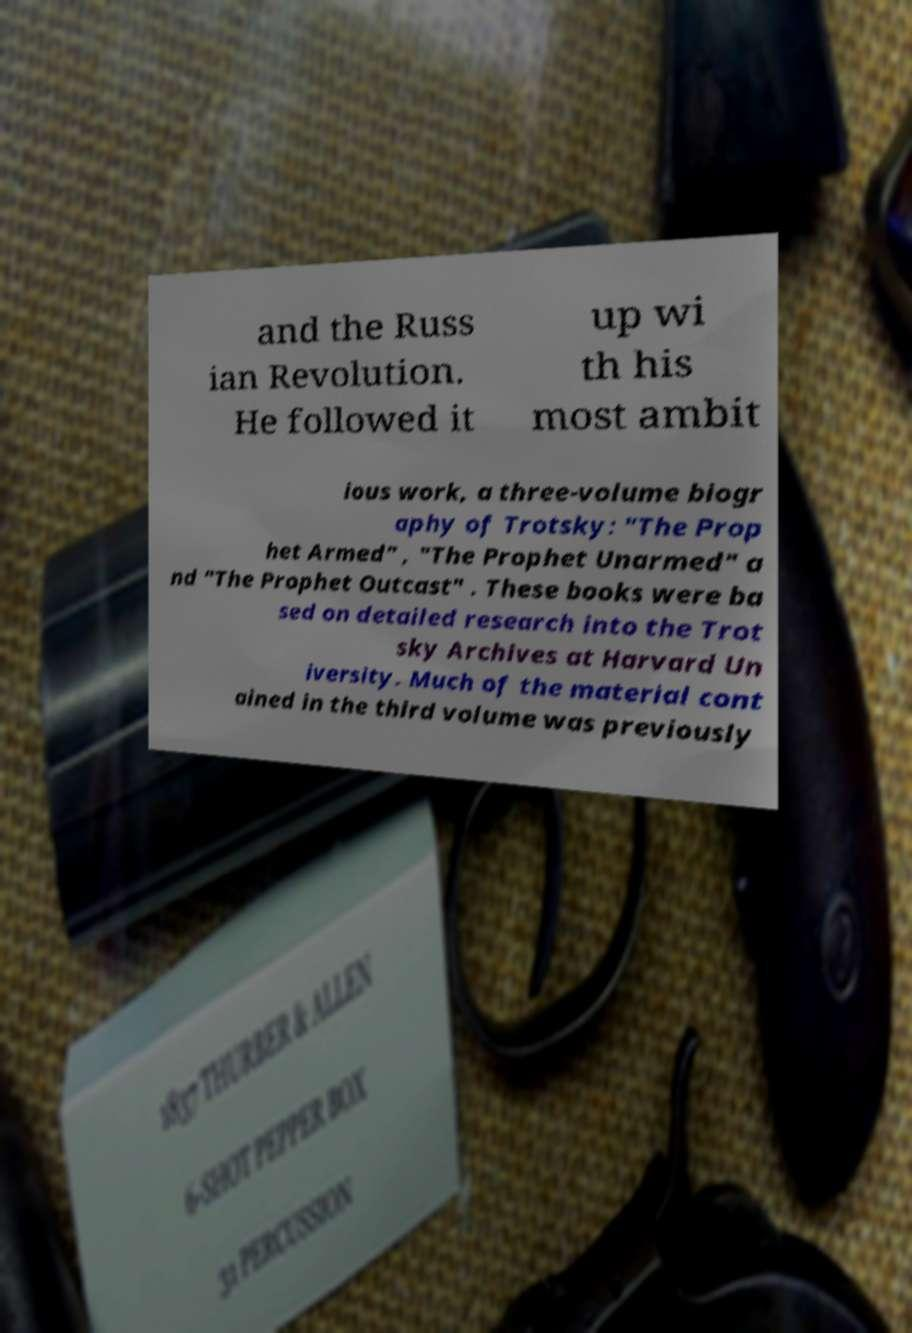I need the written content from this picture converted into text. Can you do that? and the Russ ian Revolution. He followed it up wi th his most ambit ious work, a three-volume biogr aphy of Trotsky: "The Prop het Armed" , "The Prophet Unarmed" a nd "The Prophet Outcast" . These books were ba sed on detailed research into the Trot sky Archives at Harvard Un iversity. Much of the material cont ained in the third volume was previously 